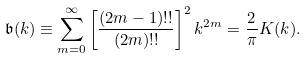Convert formula to latex. <formula><loc_0><loc_0><loc_500><loc_500>\mathfrak { b } ( k ) \equiv \sum _ { m = 0 } ^ { \infty } \left [ \frac { ( 2 m - 1 ) ! ! } { ( 2 m ) ! ! } \right ] ^ { 2 } k ^ { 2 m } = \frac { 2 } { \pi } K ( k ) .</formula> 